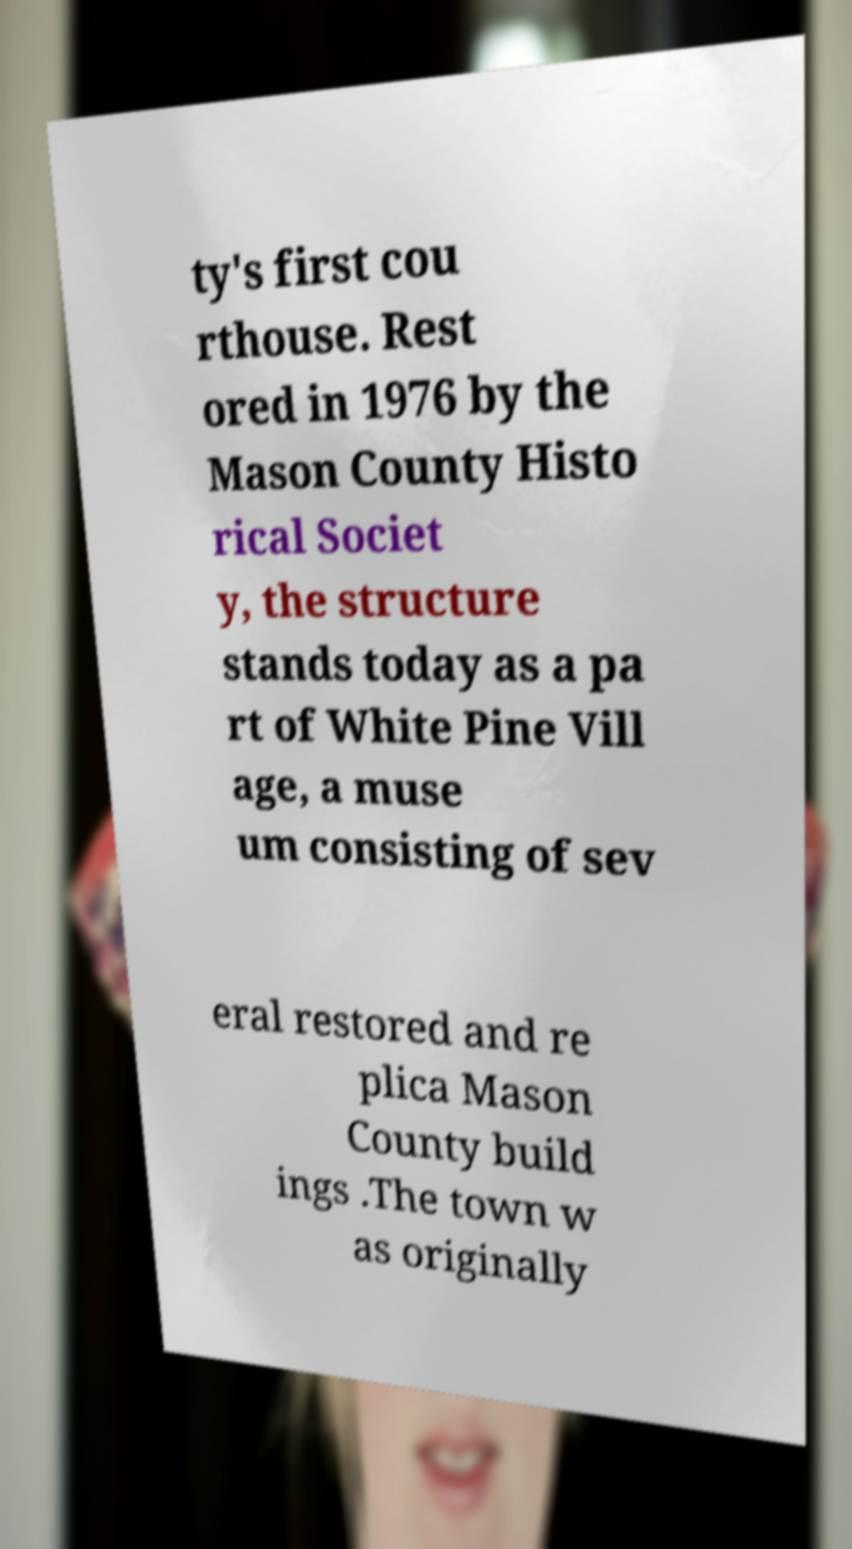I need the written content from this picture converted into text. Can you do that? ty's first cou rthouse. Rest ored in 1976 by the Mason County Histo rical Societ y, the structure stands today as a pa rt of White Pine Vill age, a muse um consisting of sev eral restored and re plica Mason County build ings .The town w as originally 